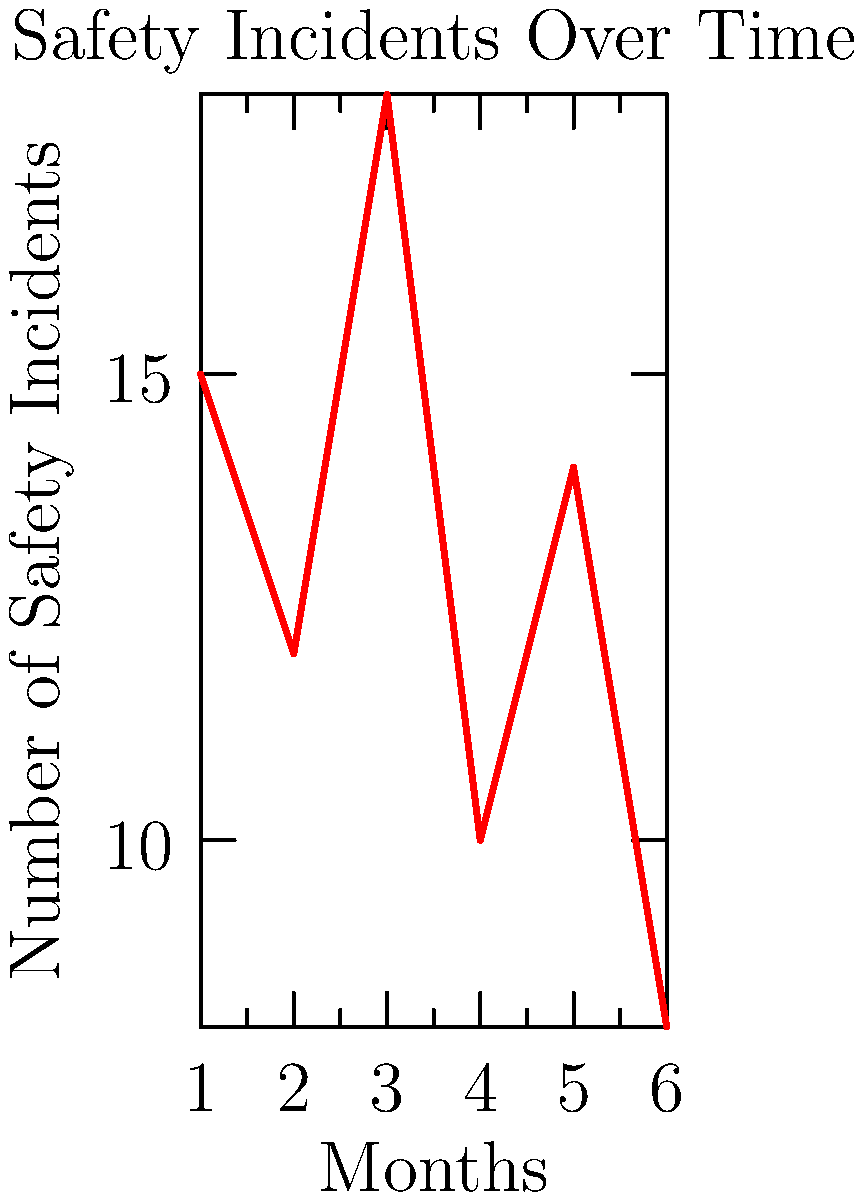Based on the trend graph of safety incidents over a 6-month period, what strategy should be implemented to continue the overall downward trend in incidents?

A) Increase staff training
B) Reduce safety measures
C) Maintain current practices
D) Implement stricter punishments for errors To answer this question, let's analyze the graph step-by-step:

1. Observe the overall trend: Despite some fluctuations, there is a general downward trend in the number of safety incidents over the 6-month period.

2. Identify key points:
   - Month 1: 15 incidents
   - Month 2: Decrease to 12 incidents
   - Month 3: Spike to 18 incidents
   - Month 4: Sharp drop to 10 incidents
   - Month 5: Slight increase to 14 incidents
   - Month 6: Decrease to 8 incidents (lowest point)

3. Interpret the data: The overall decrease suggests that current safety measures are having a positive effect, but there's still room for improvement given the fluctuations.

4. Consider the options:
   A) Increase staff training: This aligns with the goal of improving safety outcomes and could help maintain the downward trend.
   B) Reduce safety measures: This would likely reverse the positive trend and is not advisable.
   C) Maintain current practices: While this might maintain the current trend, it doesn't address the fluctuations or aim for further improvement.
   D) Implement stricter punishments: This approach doesn't address the root causes of safety incidents and may negatively impact staff morale.

5. Conclusion: The best strategy to continue the overall downward trend is to increase staff training (option A). This approach can help address the fluctuations, reinforce good practices, and potentially lead to further reductions in safety incidents.
Answer: A) Increase staff training 